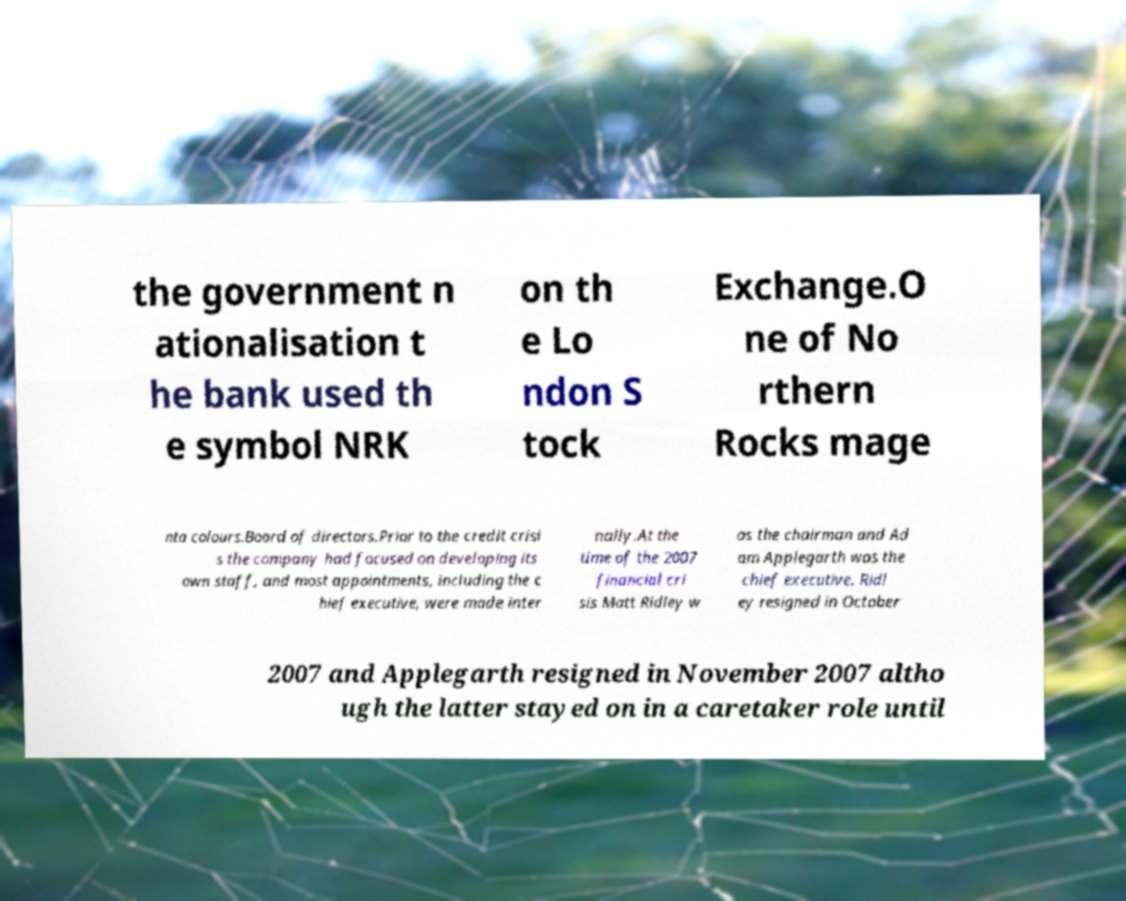Please read and relay the text visible in this image. What does it say? the government n ationalisation t he bank used th e symbol NRK on th e Lo ndon S tock Exchange.O ne of No rthern Rocks mage nta colours.Board of directors.Prior to the credit crisi s the company had focused on developing its own staff, and most appointments, including the c hief executive, were made inter nally.At the time of the 2007 financial cri sis Matt Ridley w as the chairman and Ad am Applegarth was the chief executive. Ridl ey resigned in October 2007 and Applegarth resigned in November 2007 altho ugh the latter stayed on in a caretaker role until 